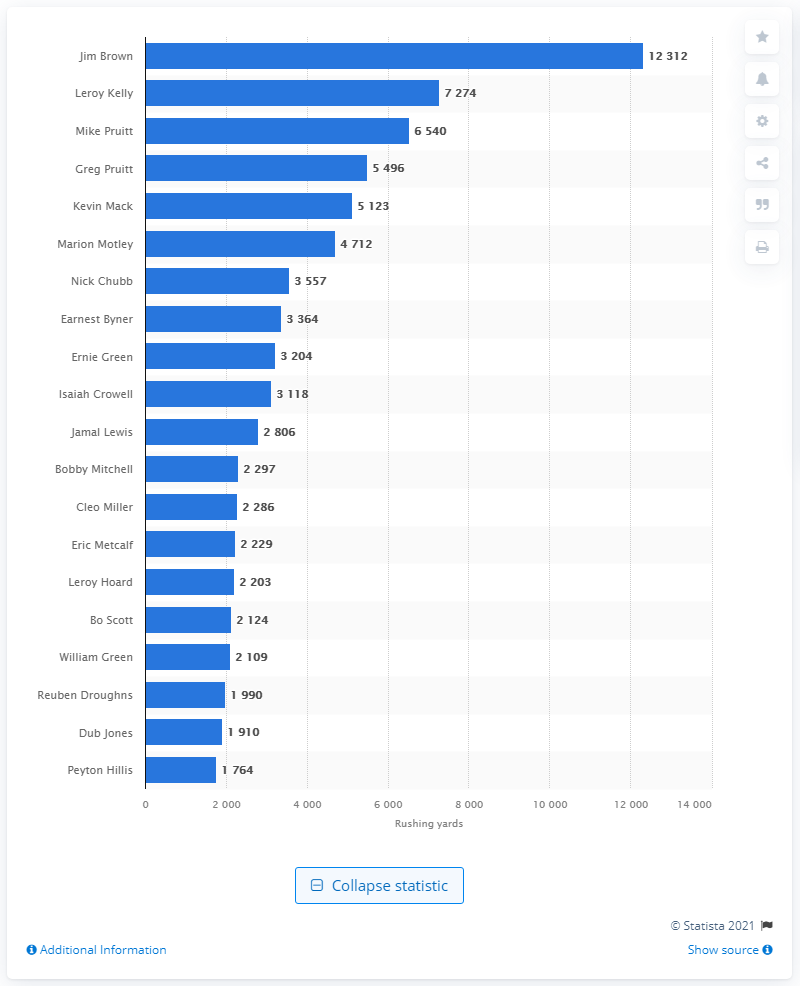List a handful of essential elements in this visual. The career rushing leader of the Cleveland Browns is Jim Brown. 